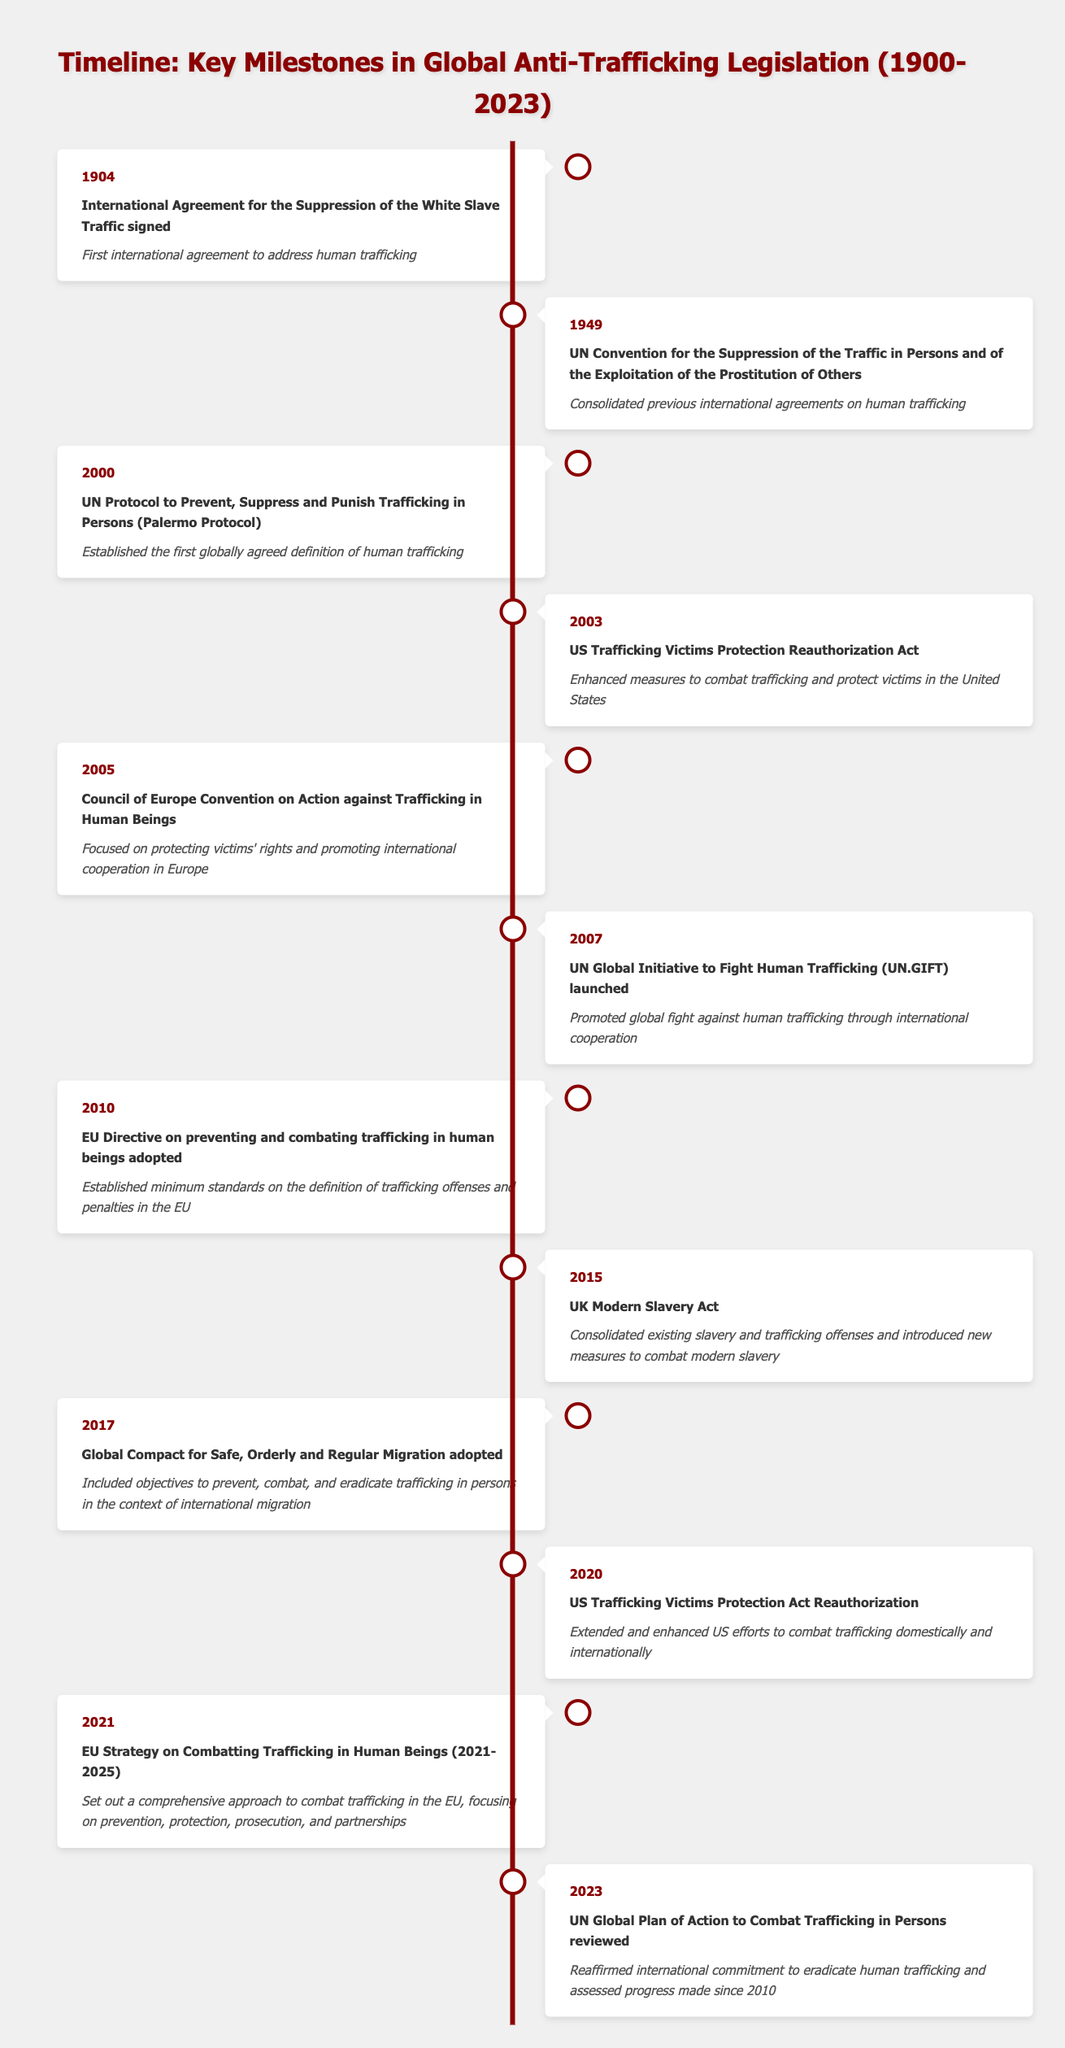What year was the International Agreement for the Suppression of the White Slave Traffic signed? The table lists the event under the year 1904. Thus, the specific year it occurred is 1904.
Answer: 1904 Which milestone event occurred in 2010? Referring to the table, in the year 2010, the event listed is the "EU Directive on preventing and combating trafficking in human beings adopted."
Answer: EU Directive on preventing and combating trafficking in human beings adopted How many total events took place from 1904 to 2023? By counting the individual events listed in the table, there are a total of 12 events spanning from 1904 to 2023.
Answer: 12 Is the UK Modern Slavery Act part of the legislation timeline? According to the table, the UK Modern Slavery Act is included and was enacted in 2015, confirming its presence in the timeline.
Answer: Yes What significant action occurred after the UN Protocol in 2000 and before the UK Modern Slavery Act? The table shows that after the UN Protocol in 2000, the next significant action listed is the US Trafficking Victims Protection Reauthorization Act in 2003, which is directly before the UK Modern Slavery Act in 2015.
Answer: US Trafficking Victims Protection Reauthorization Act How many years separate the signing of the International Agreement in 1904 and the adoption of the EU Strategy in 2021? The difference can be calculated by subtracting the years: 2021 - 1904 = 117 years. Thus, it takes 117 years from the first event to the latter.
Answer: 117 years What is the significance of the 2005 Council of Europe Convention? The table states that the significance of this 2005 event focuses on protecting victims' rights and promoting international cooperation in Europe.
Answer: Focused on protecting victims' rights and promoting international cooperation in Europe Was the Global Compact for Safe, Orderly and Regular Migration adopted before or after the 2010 EU Directive? The table indicates that the Global Compact for Safe, Orderly and Regular Migration was adopted in 2017, which is after the EU Directive enacted in 2010.
Answer: After 